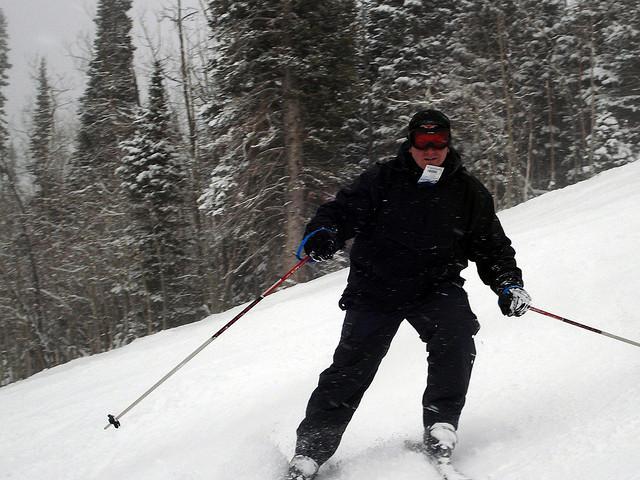Is there snow on the ground?
Be succinct. Yes. Why is the skier pointed this way on the mountain?
Short answer required. Posing. What color are his ski poles?
Concise answer only. Black. What sport is this?
Short answer required. Skiing. Why might this skier be involved in some kind of competition?
Write a very short answer. Tag on jacket. What color is his jacket?
Be succinct. Black. 